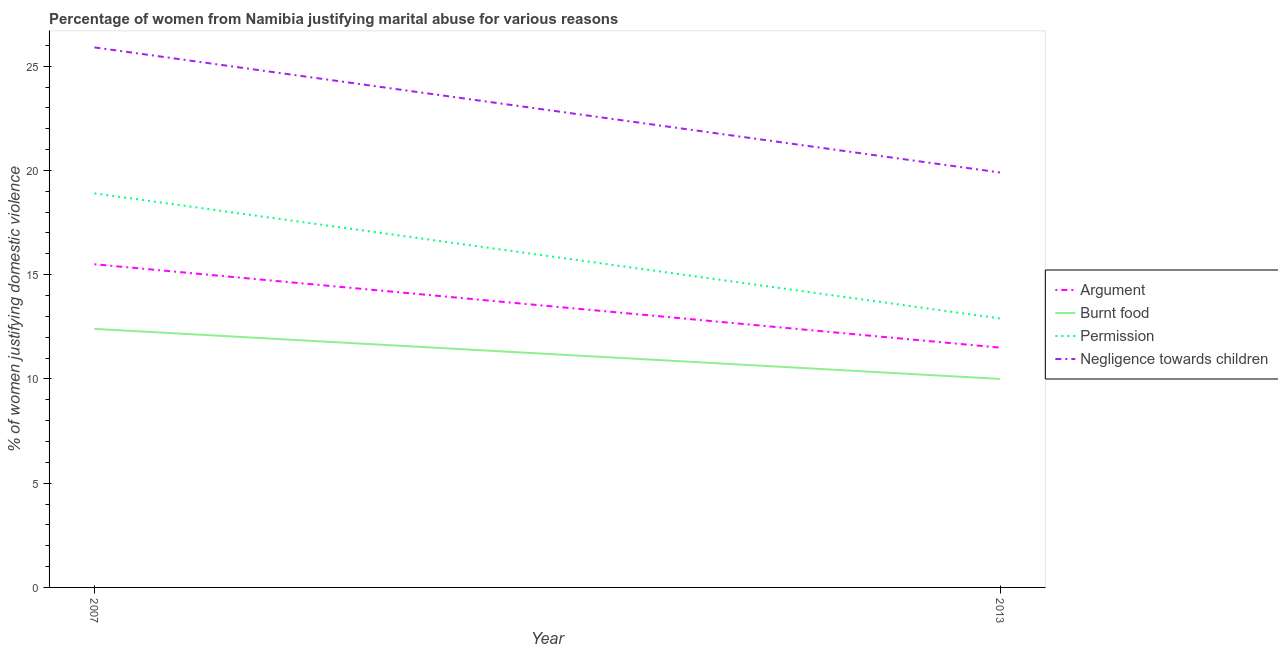Is the number of lines equal to the number of legend labels?
Ensure brevity in your answer.  Yes. What is the percentage of women justifying abuse for going without permission in 2007?
Provide a succinct answer. 18.9. Across all years, what is the maximum percentage of women justifying abuse in the case of an argument?
Ensure brevity in your answer.  15.5. In which year was the percentage of women justifying abuse for showing negligence towards children maximum?
Ensure brevity in your answer.  2007. What is the total percentage of women justifying abuse for going without permission in the graph?
Provide a succinct answer. 31.8. What is the difference between the percentage of women justifying abuse for burning food in 2007 and that in 2013?
Offer a terse response. 2.4. What is the difference between the percentage of women justifying abuse for showing negligence towards children in 2007 and the percentage of women justifying abuse for going without permission in 2013?
Your answer should be compact. 13. In the year 2013, what is the difference between the percentage of women justifying abuse for burning food and percentage of women justifying abuse in the case of an argument?
Your response must be concise. -1.5. What is the ratio of the percentage of women justifying abuse for showing negligence towards children in 2007 to that in 2013?
Offer a very short reply. 1.3. In how many years, is the percentage of women justifying abuse for burning food greater than the average percentage of women justifying abuse for burning food taken over all years?
Offer a very short reply. 1. Is the percentage of women justifying abuse for burning food strictly greater than the percentage of women justifying abuse in the case of an argument over the years?
Your response must be concise. No. Is the percentage of women justifying abuse for going without permission strictly less than the percentage of women justifying abuse for showing negligence towards children over the years?
Your answer should be very brief. Yes. Are the values on the major ticks of Y-axis written in scientific E-notation?
Your response must be concise. No. Where does the legend appear in the graph?
Your response must be concise. Center right. How many legend labels are there?
Ensure brevity in your answer.  4. What is the title of the graph?
Provide a succinct answer. Percentage of women from Namibia justifying marital abuse for various reasons. Does "First 20% of population" appear as one of the legend labels in the graph?
Your response must be concise. No. What is the label or title of the X-axis?
Make the answer very short. Year. What is the label or title of the Y-axis?
Your answer should be very brief. % of women justifying domestic violence. What is the % of women justifying domestic violence of Argument in 2007?
Your response must be concise. 15.5. What is the % of women justifying domestic violence in Burnt food in 2007?
Offer a very short reply. 12.4. What is the % of women justifying domestic violence of Permission in 2007?
Ensure brevity in your answer.  18.9. What is the % of women justifying domestic violence in Negligence towards children in 2007?
Provide a short and direct response. 25.9. What is the % of women justifying domestic violence in Burnt food in 2013?
Make the answer very short. 10. What is the % of women justifying domestic violence in Permission in 2013?
Give a very brief answer. 12.9. Across all years, what is the maximum % of women justifying domestic violence in Argument?
Your response must be concise. 15.5. Across all years, what is the maximum % of women justifying domestic violence in Burnt food?
Provide a succinct answer. 12.4. Across all years, what is the maximum % of women justifying domestic violence of Negligence towards children?
Make the answer very short. 25.9. Across all years, what is the minimum % of women justifying domestic violence of Burnt food?
Your response must be concise. 10. Across all years, what is the minimum % of women justifying domestic violence in Permission?
Your response must be concise. 12.9. Across all years, what is the minimum % of women justifying domestic violence of Negligence towards children?
Your answer should be very brief. 19.9. What is the total % of women justifying domestic violence in Burnt food in the graph?
Make the answer very short. 22.4. What is the total % of women justifying domestic violence in Permission in the graph?
Make the answer very short. 31.8. What is the total % of women justifying domestic violence in Negligence towards children in the graph?
Make the answer very short. 45.8. What is the difference between the % of women justifying domestic violence of Burnt food in 2007 and that in 2013?
Give a very brief answer. 2.4. What is the difference between the % of women justifying domestic violence in Argument in 2007 and the % of women justifying domestic violence in Burnt food in 2013?
Your answer should be very brief. 5.5. What is the difference between the % of women justifying domestic violence of Argument in 2007 and the % of women justifying domestic violence of Negligence towards children in 2013?
Your answer should be compact. -4.4. What is the difference between the % of women justifying domestic violence in Burnt food in 2007 and the % of women justifying domestic violence in Negligence towards children in 2013?
Your answer should be compact. -7.5. What is the difference between the % of women justifying domestic violence in Permission in 2007 and the % of women justifying domestic violence in Negligence towards children in 2013?
Keep it short and to the point. -1. What is the average % of women justifying domestic violence in Argument per year?
Keep it short and to the point. 13.5. What is the average % of women justifying domestic violence of Burnt food per year?
Make the answer very short. 11.2. What is the average % of women justifying domestic violence of Negligence towards children per year?
Offer a terse response. 22.9. In the year 2007, what is the difference between the % of women justifying domestic violence in Argument and % of women justifying domestic violence in Burnt food?
Offer a terse response. 3.1. In the year 2007, what is the difference between the % of women justifying domestic violence of Argument and % of women justifying domestic violence of Permission?
Give a very brief answer. -3.4. In the year 2007, what is the difference between the % of women justifying domestic violence of Argument and % of women justifying domestic violence of Negligence towards children?
Your response must be concise. -10.4. In the year 2013, what is the difference between the % of women justifying domestic violence of Argument and % of women justifying domestic violence of Negligence towards children?
Your response must be concise. -8.4. In the year 2013, what is the difference between the % of women justifying domestic violence of Burnt food and % of women justifying domestic violence of Permission?
Offer a terse response. -2.9. What is the ratio of the % of women justifying domestic violence of Argument in 2007 to that in 2013?
Ensure brevity in your answer.  1.35. What is the ratio of the % of women justifying domestic violence in Burnt food in 2007 to that in 2013?
Your answer should be very brief. 1.24. What is the ratio of the % of women justifying domestic violence of Permission in 2007 to that in 2013?
Make the answer very short. 1.47. What is the ratio of the % of women justifying domestic violence of Negligence towards children in 2007 to that in 2013?
Keep it short and to the point. 1.3. What is the difference between the highest and the second highest % of women justifying domestic violence of Argument?
Offer a very short reply. 4. What is the difference between the highest and the second highest % of women justifying domestic violence in Burnt food?
Give a very brief answer. 2.4. What is the difference between the highest and the second highest % of women justifying domestic violence of Permission?
Give a very brief answer. 6. What is the difference between the highest and the second highest % of women justifying domestic violence of Negligence towards children?
Give a very brief answer. 6. What is the difference between the highest and the lowest % of women justifying domestic violence in Negligence towards children?
Provide a short and direct response. 6. 